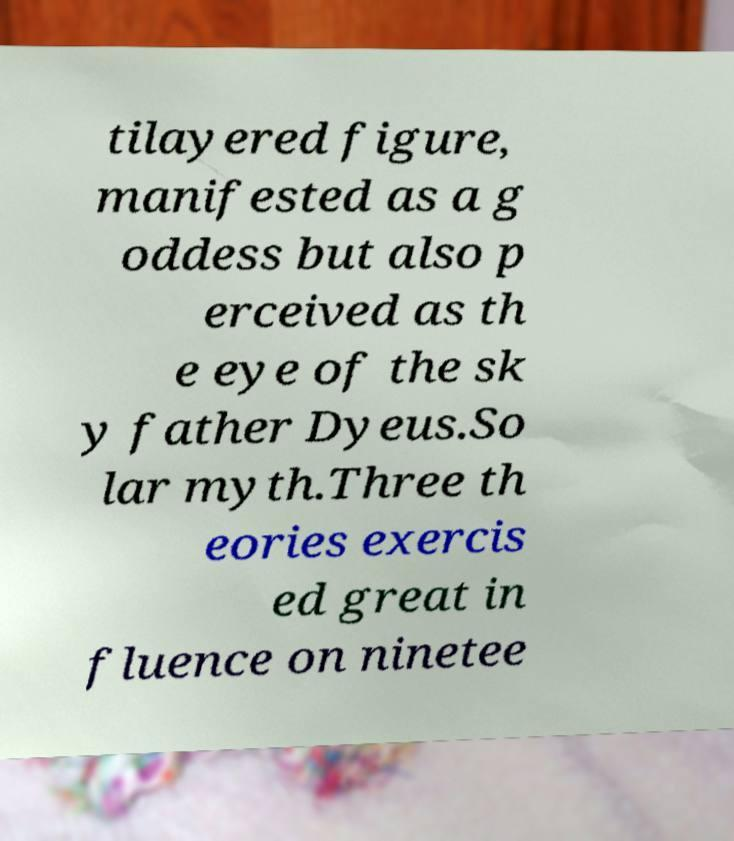Can you read and provide the text displayed in the image?This photo seems to have some interesting text. Can you extract and type it out for me? tilayered figure, manifested as a g oddess but also p erceived as th e eye of the sk y father Dyeus.So lar myth.Three th eories exercis ed great in fluence on ninetee 